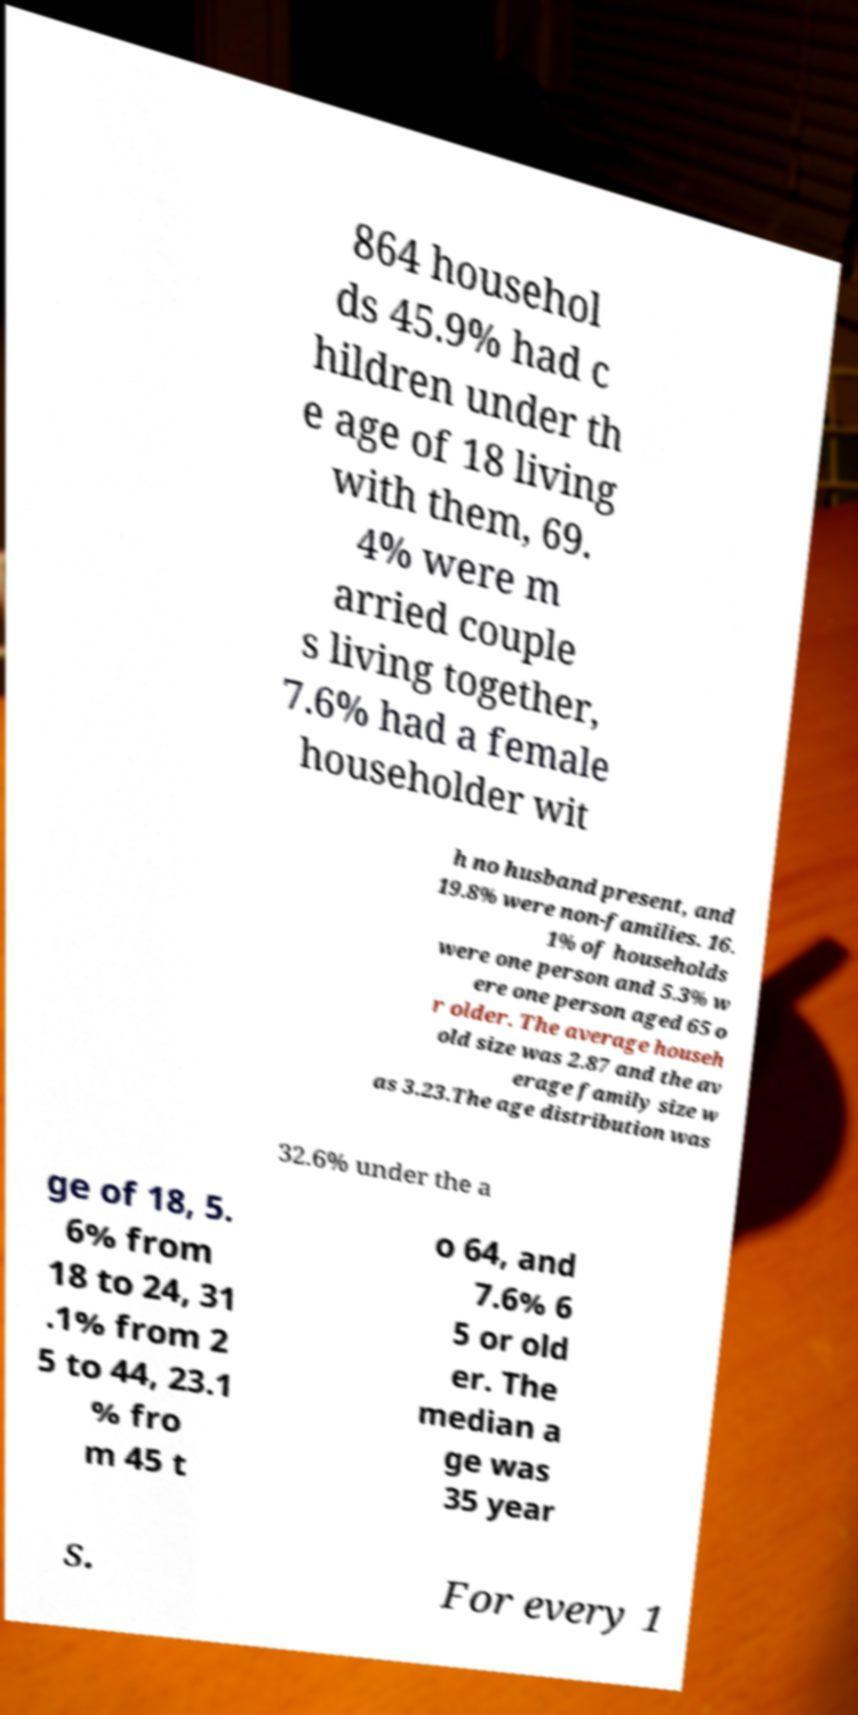Please identify and transcribe the text found in this image. 864 househol ds 45.9% had c hildren under th e age of 18 living with them, 69. 4% were m arried couple s living together, 7.6% had a female householder wit h no husband present, and 19.8% were non-families. 16. 1% of households were one person and 5.3% w ere one person aged 65 o r older. The average househ old size was 2.87 and the av erage family size w as 3.23.The age distribution was 32.6% under the a ge of 18, 5. 6% from 18 to 24, 31 .1% from 2 5 to 44, 23.1 % fro m 45 t o 64, and 7.6% 6 5 or old er. The median a ge was 35 year s. For every 1 